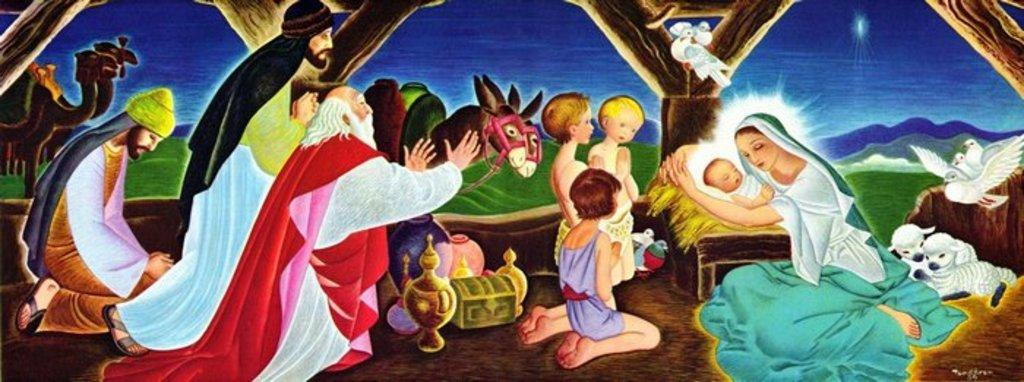Who or what is shown in the image? There are people and birds depicted in the image. Can you describe the environment in the image? The background of the image includes grass, and the sky is visible in the background. How many sheep are present in the image? There are 2 sheep in the image. What else can be seen in the image besides the people, birds, and sheep? There are unspecified things in the image. What type of cup is being used to make a suggestion in the image? There is no cup or suggestion present in the image. What does the self think about the birds in the image? The concept of "self" is not applicable in this context, as the image is a representation of people, birds, and other elements, not a personal experience or thought. 